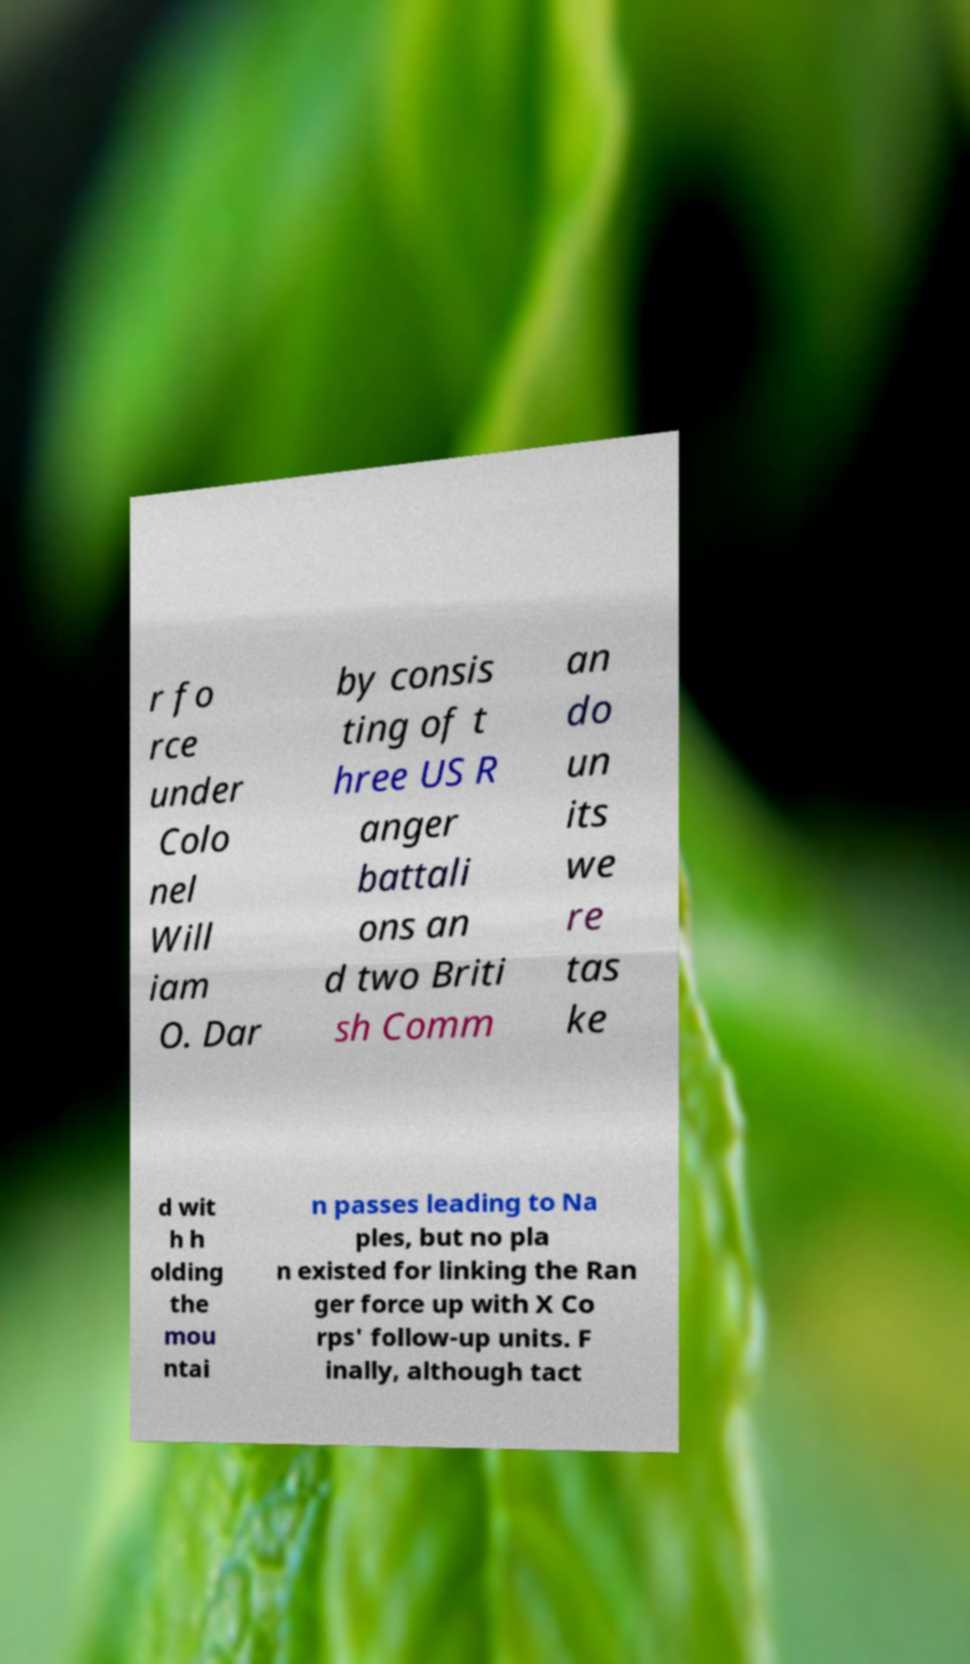Can you read and provide the text displayed in the image?This photo seems to have some interesting text. Can you extract and type it out for me? r fo rce under Colo nel Will iam O. Dar by consis ting of t hree US R anger battali ons an d two Briti sh Comm an do un its we re tas ke d wit h h olding the mou ntai n passes leading to Na ples, but no pla n existed for linking the Ran ger force up with X Co rps' follow-up units. F inally, although tact 